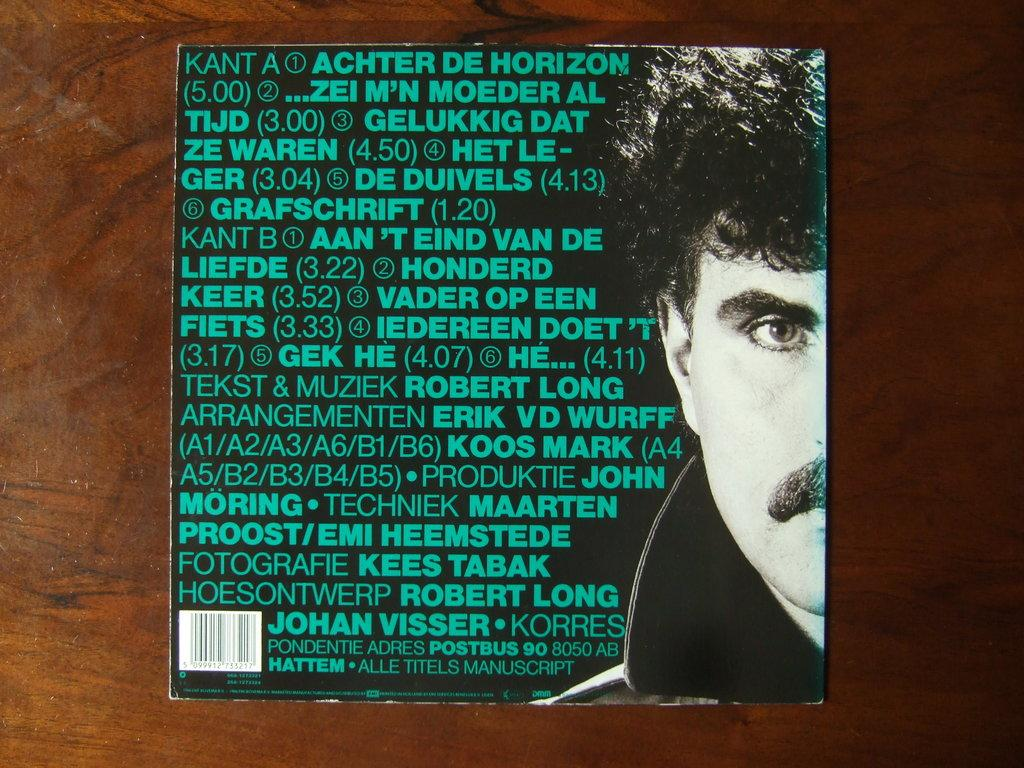What is the main subject of the image? There is a person's face in the image. What can be seen written on an object in the image? There is something written on a black object in the image. What is the color of the surface the black object is placed on? The black object is on a brown surface in the image. What type of hen is depicted in the image? There is no hen present in the image; it features a person's face and a black object with writing on it. 